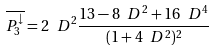<formula> <loc_0><loc_0><loc_500><loc_500>\overline { P _ { 3 } ^ { \downarrow } } = 2 \ D ^ { 2 } \frac { 1 3 - 8 \ D ^ { 2 } + 1 6 \ D ^ { 4 } } { ( 1 + 4 \ D ^ { 2 } ) ^ { 2 } }</formula> 